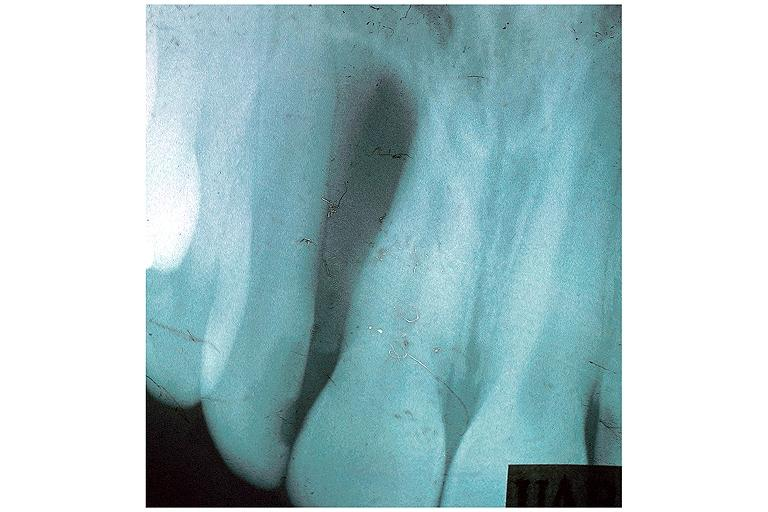where is this?
Answer the question using a single word or phrase. Oral 